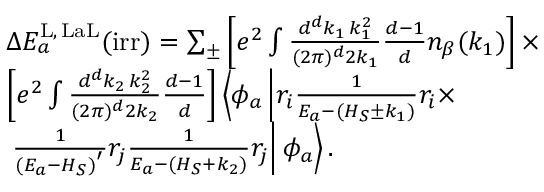<formula> <loc_0><loc_0><loc_500><loc_500>\begin{array} { r l } & { \Delta E _ { a } ^ { L , \, L a L } ( i r r ) = \sum _ { \pm } \left [ e ^ { 2 } \int \frac { d ^ { d } k _ { 1 } \, k _ { 1 } ^ { 2 } } { ( 2 \pi ) ^ { d } 2 k _ { 1 } } \frac { d - 1 } { d } n _ { \beta } ( k _ { 1 } ) \right ] \times } \\ & { \left [ e ^ { 2 } \int \frac { d ^ { d } k _ { 2 } \, k _ { 2 } ^ { 2 } } { ( 2 \pi ) ^ { d } 2 k _ { 2 } } \frac { d - 1 } { d } \right ] \left \langle \phi _ { a } \left | r _ { i } \frac { 1 } { E _ { a } - ( H _ { S } \pm k _ { 1 } ) } r _ { i } \times } \\ & { \frac { 1 } { ( E _ { a } - H _ { S } ) ^ { ^ { \prime } } } r _ { j } \frac { 1 } { E _ { a } - ( H _ { S } + k _ { 2 } ) } r _ { j } \right | \phi _ { a } \right \rangle . } \end{array}</formula> 